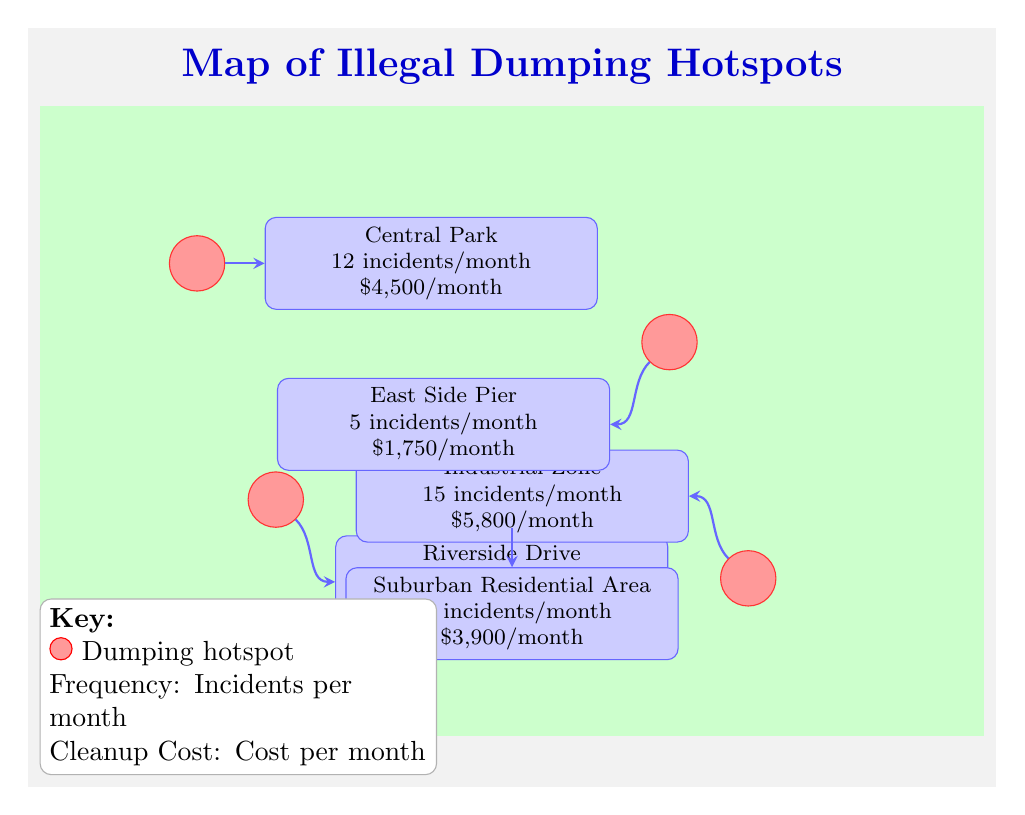What is the incident frequency at Central Park? The diagram indicates that Central Park has 12 incidents per month, shown in the annotation associated with the hotspot.
Answer: 12 incidents/month What is the monthly cleanup cost for the Industrial Zone? The Industrial Zone annotation specifies a cleanup cost of $5,800 per month, which directly addresses the query about its cleanup cost.
Answer: $5,800/month Which area has the highest number of incidents per month? By comparing the incident frequencies among the hotspots, the Industrial Zone shows the highest number at 15 incidents per month, making it the area with the highest frequency.
Answer: Industrial Zone What is the total number of hotspots shown on the map? The diagram features five distinct hotspots identified in the locations described, counting each of them provides the total.
Answer: 5 hotspots How many incidents are reported per month at the East Side Pier? According to the annotation for the East Side Pier, it has 5 incidents per month, which is clearly outlined in its respective description.
Answer: 5 incidents/month Which location has the lowest cleanup cost? By reviewing the cleanup costs annotated for each hotspot, the East Side Pier has the lowest at $1,750 per month, thus answering the question effectively.
Answer: East Side Pier Which area experiences 10 incidents per month? The Suburban Residential Area is noted as having 10 incidents per month in its annotation. This directly identifies the area with the specified frequency.
Answer: Suburban Residential Area What is the combined total of incidents for Central Park and Riverside Drive? Central Park has 12 incidents and Riverside Drive has 8 incidents. Adding these two values together yields 20 incidents per month in total.
Answer: 20 incidents/month 